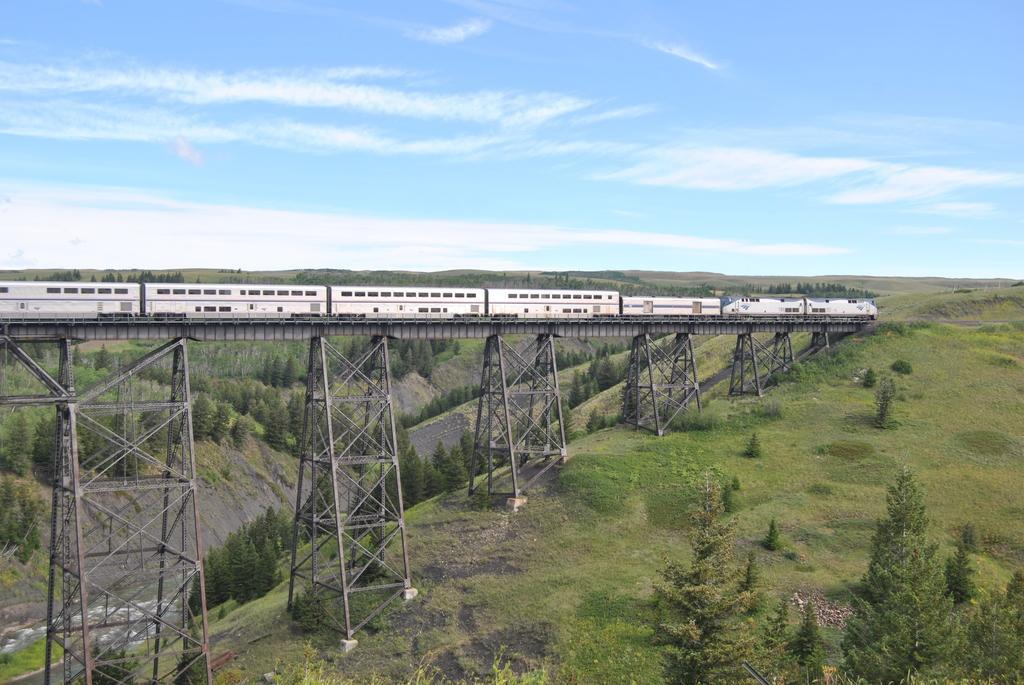Can you describe this image briefly? In this image we can see a train on the railway track, bridge, grills, trees and sky with clouds. 